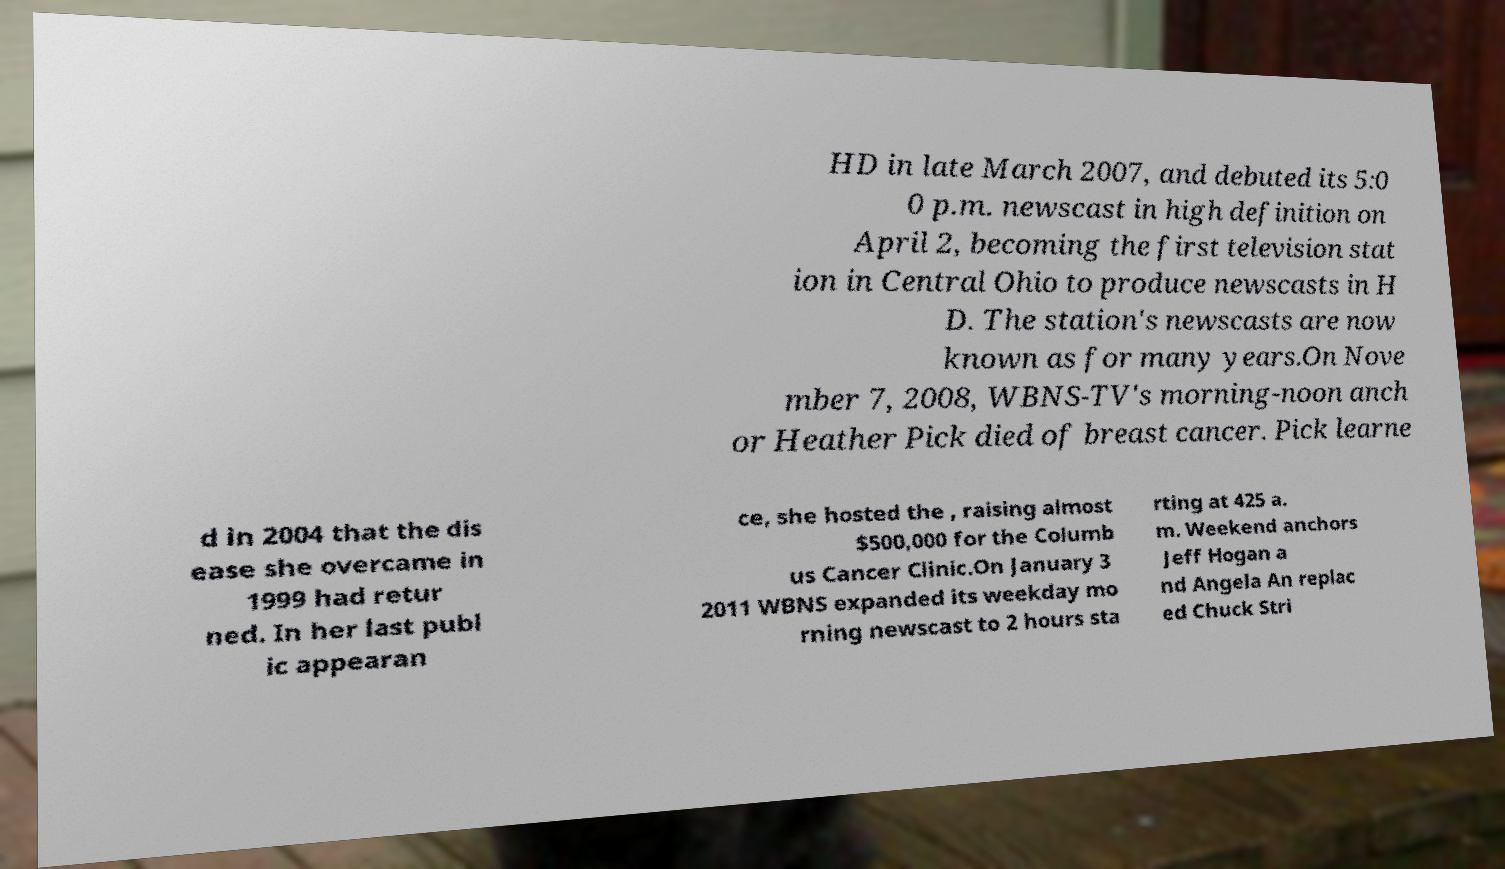What messages or text are displayed in this image? I need them in a readable, typed format. HD in late March 2007, and debuted its 5:0 0 p.m. newscast in high definition on April 2, becoming the first television stat ion in Central Ohio to produce newscasts in H D. The station's newscasts are now known as for many years.On Nove mber 7, 2008, WBNS-TV's morning-noon anch or Heather Pick died of breast cancer. Pick learne d in 2004 that the dis ease she overcame in 1999 had retur ned. In her last publ ic appearan ce, she hosted the , raising almost $500,000 for the Columb us Cancer Clinic.On January 3 2011 WBNS expanded its weekday mo rning newscast to 2 hours sta rting at 425 a. m. Weekend anchors Jeff Hogan a nd Angela An replac ed Chuck Stri 